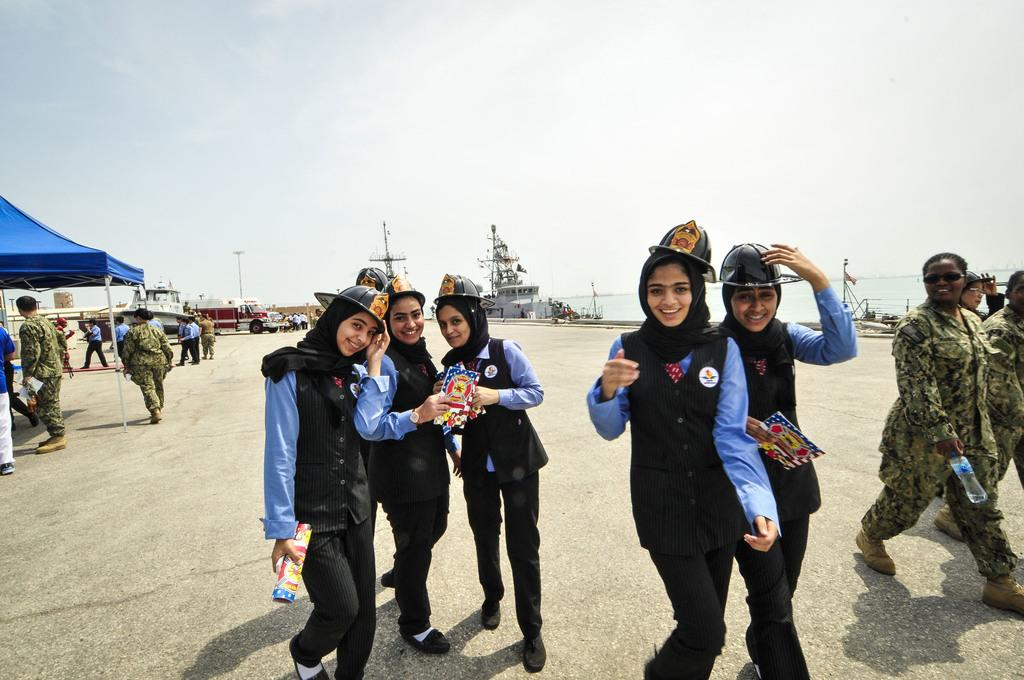What are the people in the image doing? There are persons walking in the image. What else can be seen in the image besides people walking? There are motor vehicles, parasols, poles, ships on the water, and the sky visible in the image. What might be used for shade in the image? Parasols are present in the image for shade. What type of transportation is present on the water in the image? Ships are present on the water in the image. How many toes are visible on the persons walking in the image? The number of toes visible on the persons walking cannot be determined from the image. What type of porter is assisting the persons walking in the image? There is no porter present in the image. 